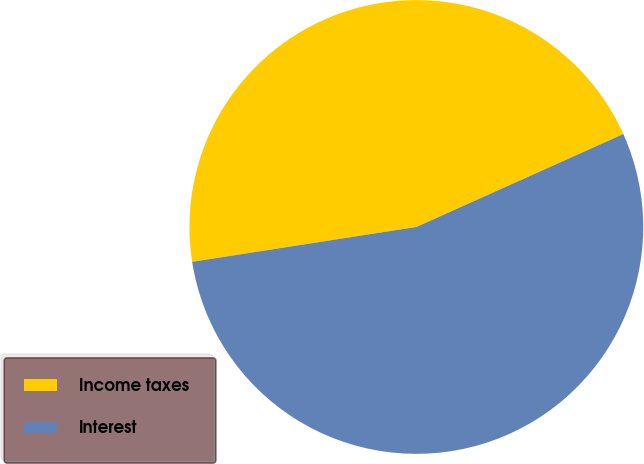Convert chart. <chart><loc_0><loc_0><loc_500><loc_500><pie_chart><fcel>Income taxes<fcel>Interest<nl><fcel>45.74%<fcel>54.26%<nl></chart> 